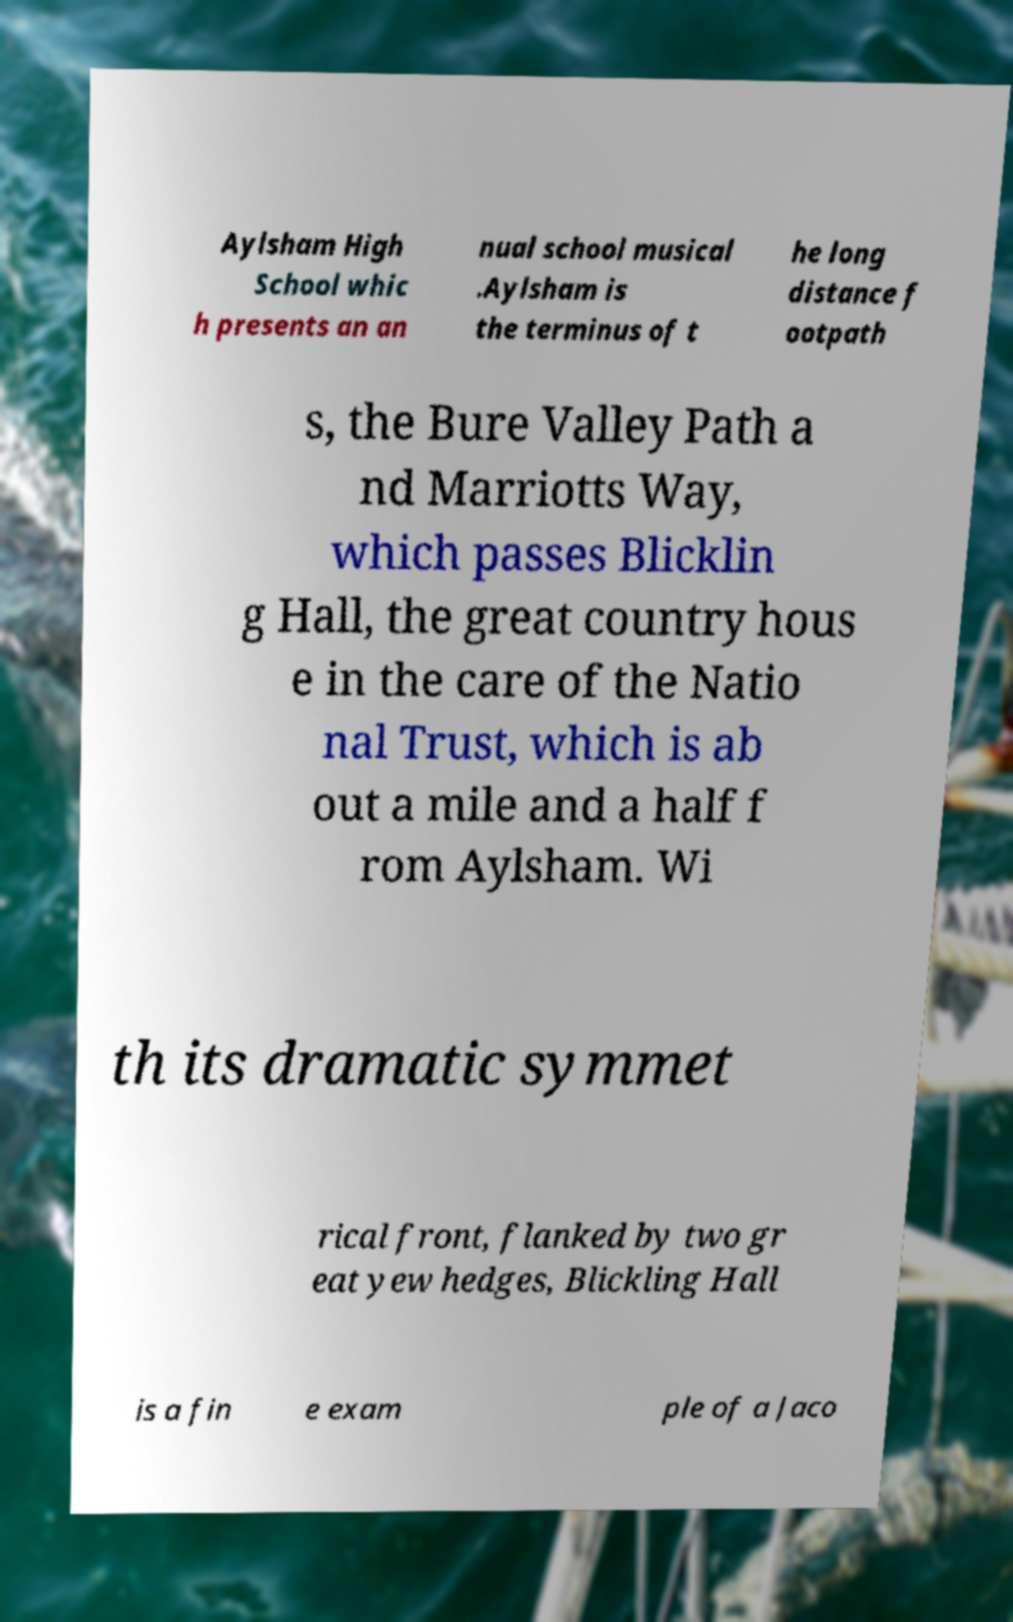There's text embedded in this image that I need extracted. Can you transcribe it verbatim? Aylsham High School whic h presents an an nual school musical .Aylsham is the terminus of t he long distance f ootpath s, the Bure Valley Path a nd Marriotts Way, which passes Blicklin g Hall, the great country hous e in the care of the Natio nal Trust, which is ab out a mile and a half f rom Aylsham. Wi th its dramatic symmet rical front, flanked by two gr eat yew hedges, Blickling Hall is a fin e exam ple of a Jaco 